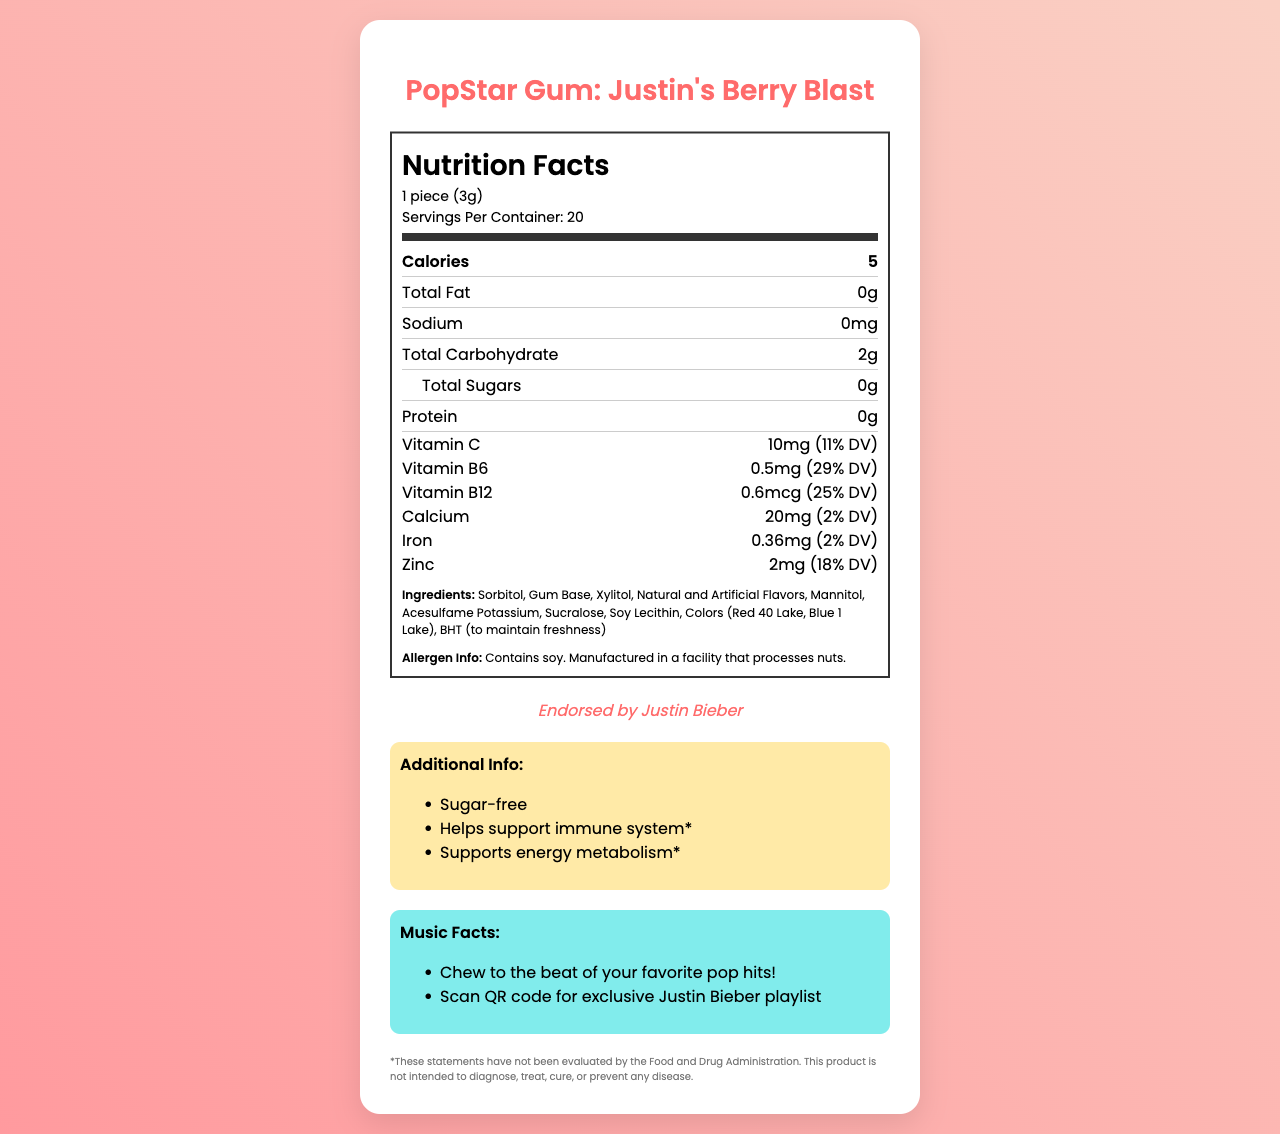what is the serving size? The serving size is listed directly in the nutrition label under the "Nutrition Facts" header.
Answer: 1 piece (3g) how many calories are in one serving? The number of calories per serving is listed in the nutrition label under "Calories".
Answer: 5 what percentage of the daily value for vitamin C does one piece provide? This information is listed in the nutrition label under "Vitamin C".
Answer: 11% does the gum contain any protein? Protein is listed as "0g" in the nutrition label.
Answer: No are there any allergens in this gum? The allergen information states that the gum contains soy and is manufactured in a facility that processes nuts.
Answer: Yes which artist endorses this product? The endorsement information states that it is "Endorsed by Justin Bieber".
Answer: Justin Bieber what is the total carbohydrate content per serving? The total carbohydrate content per serving is listed as "2g" in the nutrition label.
Answer: 2g how many servings are there in a container? The number of servings per container is listed under the serving size information.
Answer: 20 multiple-choice: Which of the following vitamins is NOT included in this product? A. Vitamin C B. Vitamin D C. Vitamin B6 D. Vitamin B12 The vitamins listed in the nutrition label are Vitamin C, Vitamin B6, and Vitamin B12.
Answer: B multiple-choice: What is one additional benefit mentioned on the label? I. Helps support immune system II. Supports bone health III. Supports energy metabolism IV. Promotes heart health The additional information lists "Helps support immune system" and "Supports energy metabolism".
Answer: I and III yes/no: Does the gum contain sugar? "Sugar-free" is listed as additional information, and the total sugars are listed as "0g" in the nutrition label.
Answer: No summary: What information is presented in the nutrition label? The label includes comprehensive information about the gum's nutritional content, ingredients, allergen information, celebrity endorsement, additional health benefits, music-related facts, and legal disclaimers. This helps consumers understand the nutritional value, potential allergens, and added benefits of the product.
Answer: The nutrition label provides the product name "PopStar Gum: Justin's Berry Blast," serving size, number of servings per container, calorie content, and the amounts of different nutrients like total fat, sodium, carbohydrates, sugars, protein, and several vitamins and minerals. It also lists ingredients, allergen information, endorsement details by Justin Bieber, additional benefits, music-related facts, and a disclaimer. unanswerable: What is the price of PopStar Gum: Justin's Berry Blast? The price of the gum is not included in the visual information on the nutrition label.
Answer: Cannot be determined 